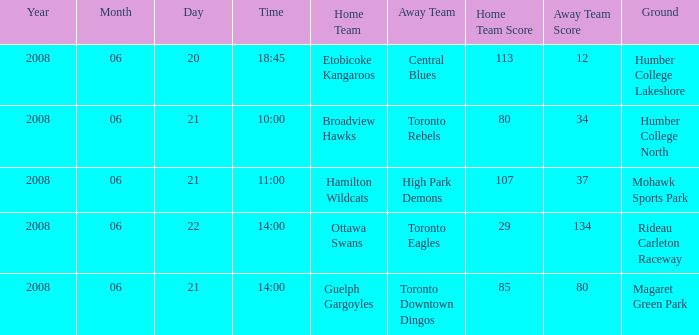What is the Date with a Home that is hamilton wildcats? 2008-06-21. 